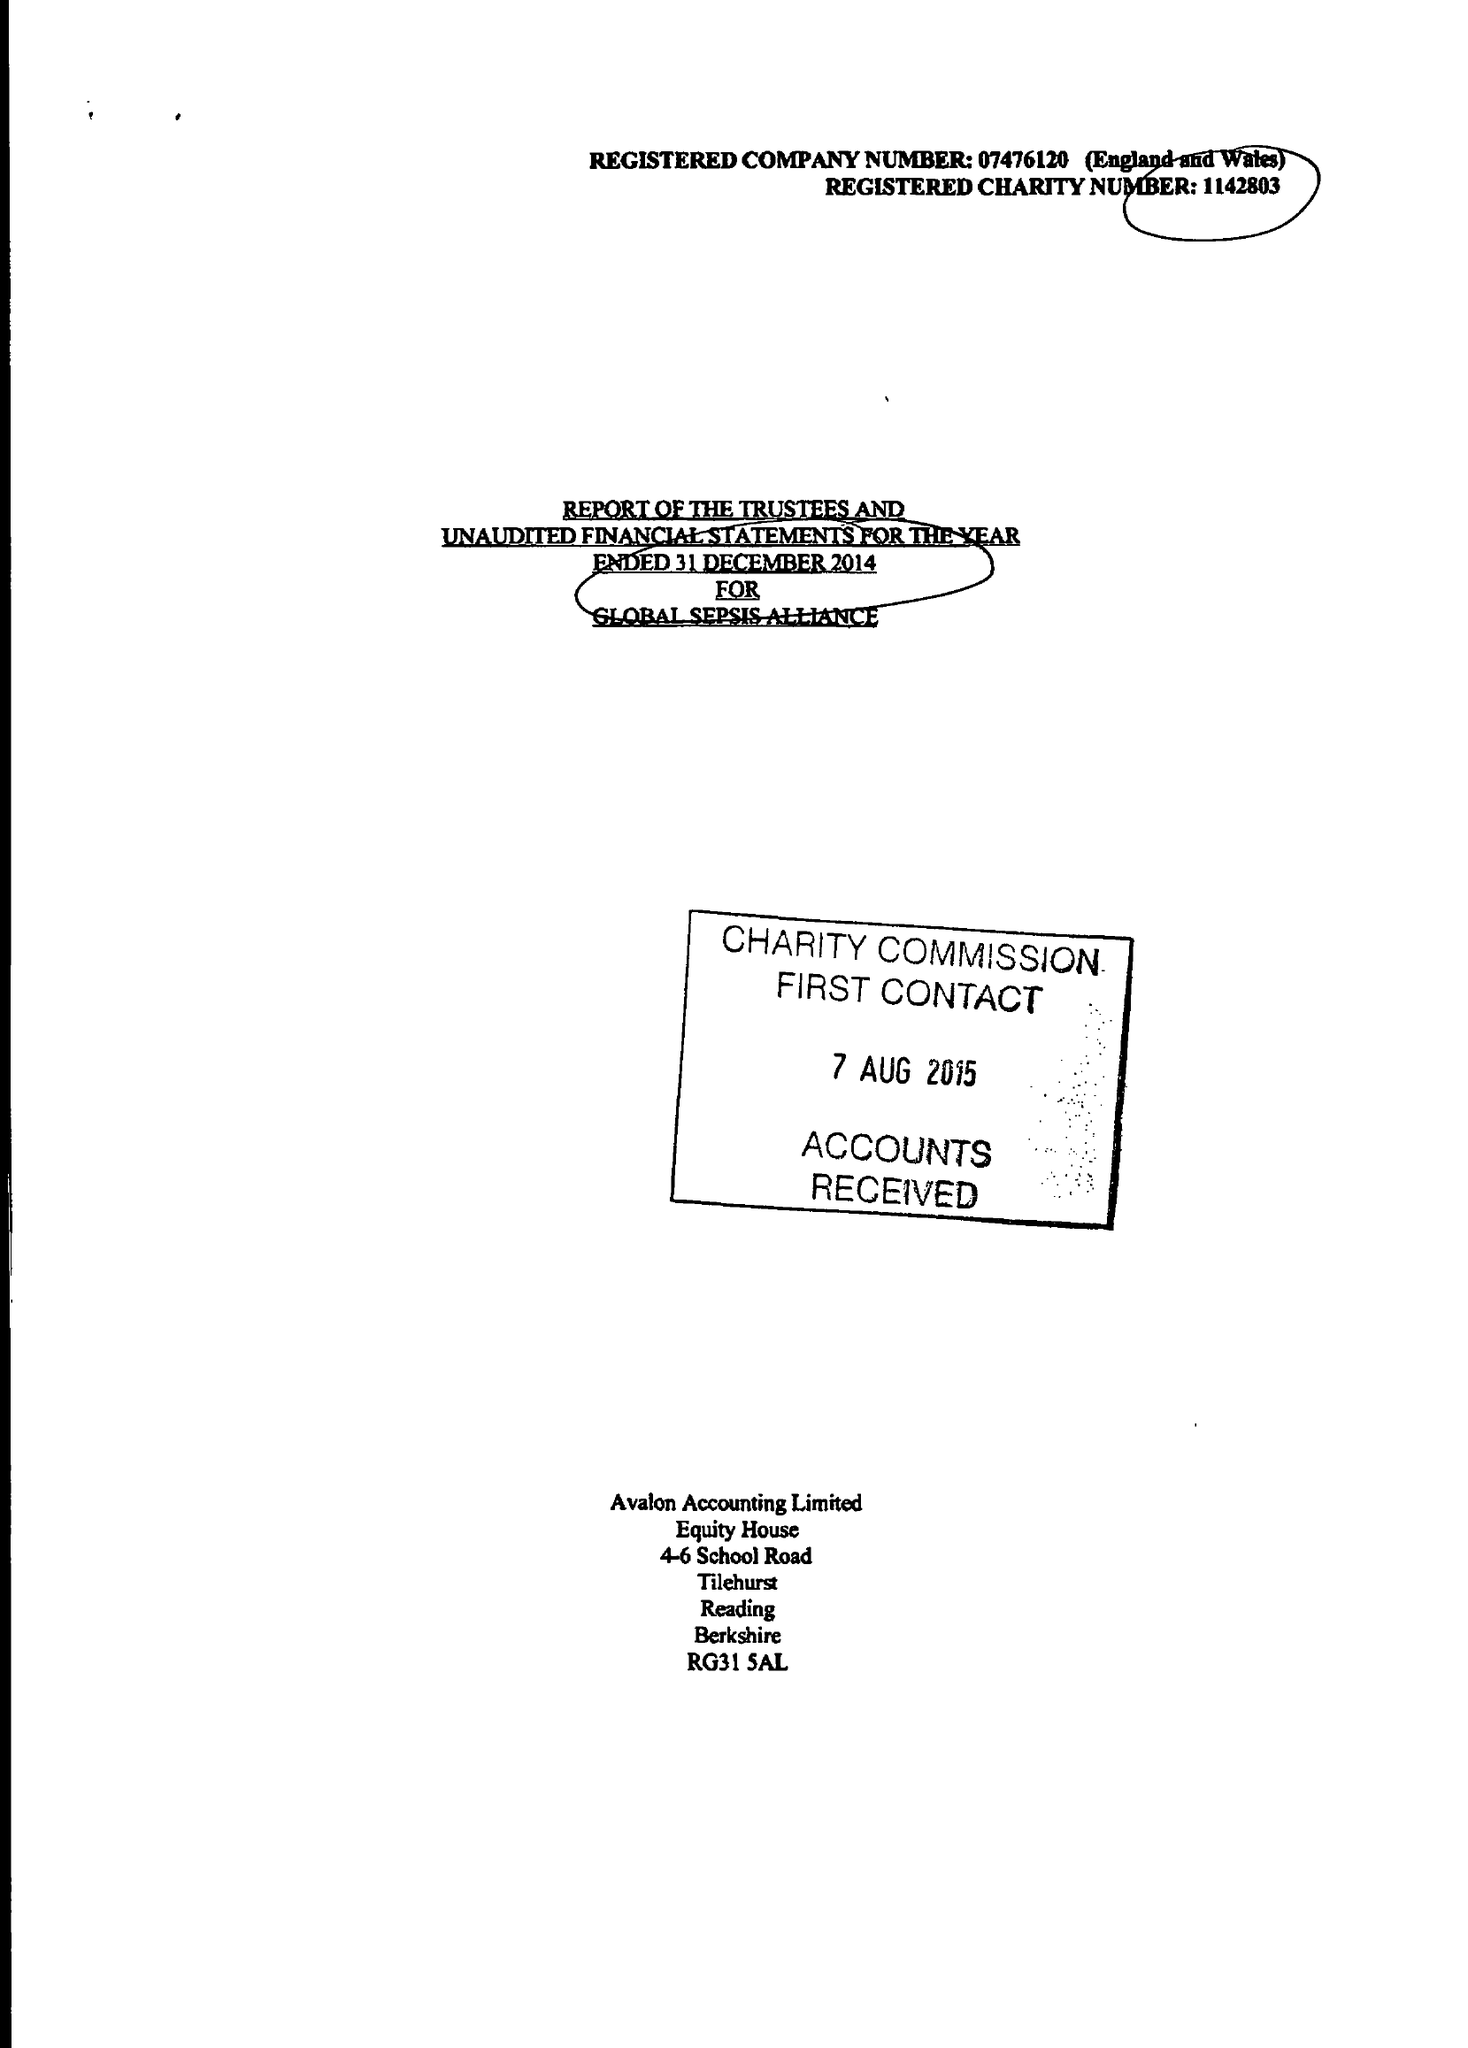What is the value for the charity_number?
Answer the question using a single word or phrase. 1142803 